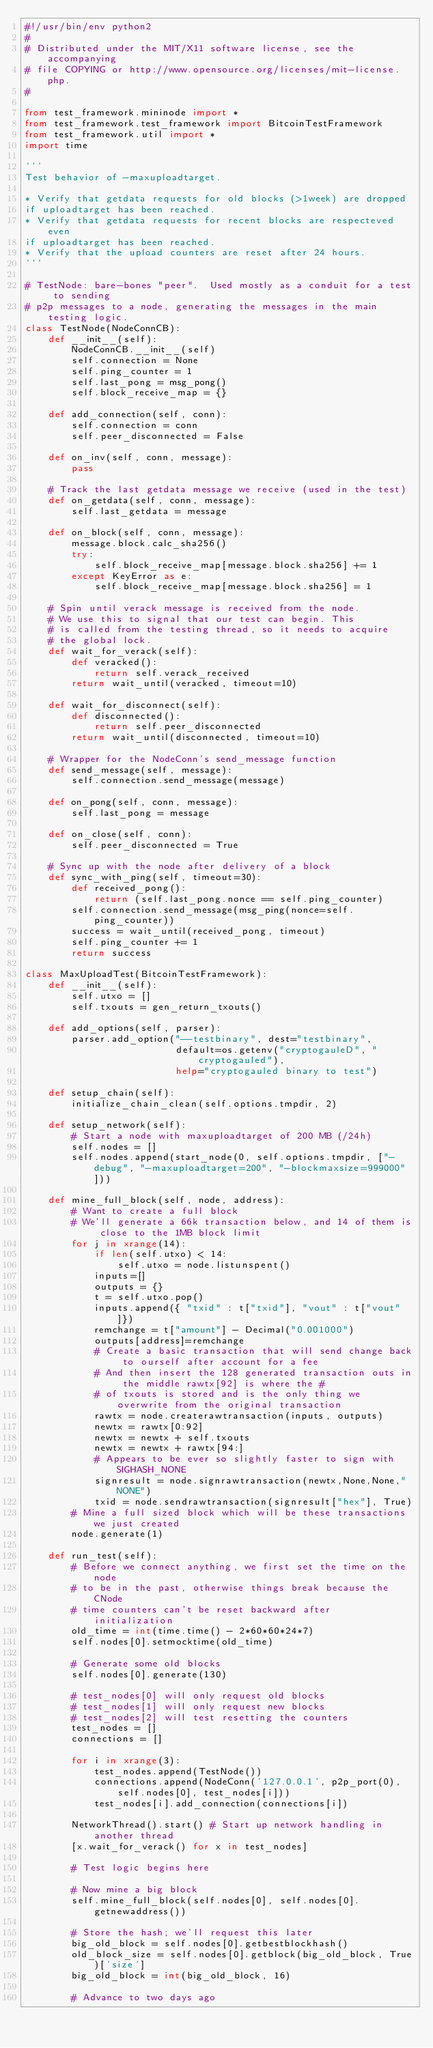<code> <loc_0><loc_0><loc_500><loc_500><_Python_>#!/usr/bin/env python2
#
# Distributed under the MIT/X11 software license, see the accompanying
# file COPYING or http://www.opensource.org/licenses/mit-license.php.
#

from test_framework.mininode import *
from test_framework.test_framework import BitcoinTestFramework
from test_framework.util import *
import time

'''
Test behavior of -maxuploadtarget.

* Verify that getdata requests for old blocks (>1week) are dropped
if uploadtarget has been reached.
* Verify that getdata requests for recent blocks are respecteved even
if uploadtarget has been reached.
* Verify that the upload counters are reset after 24 hours.
'''

# TestNode: bare-bones "peer".  Used mostly as a conduit for a test to sending
# p2p messages to a node, generating the messages in the main testing logic.
class TestNode(NodeConnCB):
    def __init__(self):
        NodeConnCB.__init__(self)
        self.connection = None
        self.ping_counter = 1
        self.last_pong = msg_pong()
        self.block_receive_map = {}

    def add_connection(self, conn):
        self.connection = conn
        self.peer_disconnected = False

    def on_inv(self, conn, message):
        pass

    # Track the last getdata message we receive (used in the test)
    def on_getdata(self, conn, message):
        self.last_getdata = message

    def on_block(self, conn, message):
        message.block.calc_sha256()
        try:
            self.block_receive_map[message.block.sha256] += 1
        except KeyError as e:
            self.block_receive_map[message.block.sha256] = 1

    # Spin until verack message is received from the node.
    # We use this to signal that our test can begin. This
    # is called from the testing thread, so it needs to acquire
    # the global lock.
    def wait_for_verack(self):
        def veracked():
            return self.verack_received
        return wait_until(veracked, timeout=10)

    def wait_for_disconnect(self):
        def disconnected():
            return self.peer_disconnected
        return wait_until(disconnected, timeout=10)

    # Wrapper for the NodeConn's send_message function
    def send_message(self, message):
        self.connection.send_message(message)

    def on_pong(self, conn, message):
        self.last_pong = message

    def on_close(self, conn):
        self.peer_disconnected = True

    # Sync up with the node after delivery of a block
    def sync_with_ping(self, timeout=30):
        def received_pong():
            return (self.last_pong.nonce == self.ping_counter)
        self.connection.send_message(msg_ping(nonce=self.ping_counter))
        success = wait_until(received_pong, timeout)
        self.ping_counter += 1
        return success

class MaxUploadTest(BitcoinTestFramework):
    def __init__(self):
        self.utxo = []
        self.txouts = gen_return_txouts()
 
    def add_options(self, parser):
        parser.add_option("--testbinary", dest="testbinary",
                          default=os.getenv("cryptogauleD", "cryptogauled"),
                          help="cryptogauled binary to test")

    def setup_chain(self):
        initialize_chain_clean(self.options.tmpdir, 2)

    def setup_network(self):
        # Start a node with maxuploadtarget of 200 MB (/24h)
        self.nodes = []
        self.nodes.append(start_node(0, self.options.tmpdir, ["-debug", "-maxuploadtarget=200", "-blockmaxsize=999000"]))

    def mine_full_block(self, node, address):
        # Want to create a full block
        # We'll generate a 66k transaction below, and 14 of them is close to the 1MB block limit
        for j in xrange(14):
            if len(self.utxo) < 14:
                self.utxo = node.listunspent()
            inputs=[]
            outputs = {}
            t = self.utxo.pop()
            inputs.append({ "txid" : t["txid"], "vout" : t["vout"]})
            remchange = t["amount"] - Decimal("0.001000")
            outputs[address]=remchange
            # Create a basic transaction that will send change back to ourself after account for a fee
            # And then insert the 128 generated transaction outs in the middle rawtx[92] is where the #
            # of txouts is stored and is the only thing we overwrite from the original transaction
            rawtx = node.createrawtransaction(inputs, outputs)
            newtx = rawtx[0:92]
            newtx = newtx + self.txouts
            newtx = newtx + rawtx[94:]
            # Appears to be ever so slightly faster to sign with SIGHASH_NONE
            signresult = node.signrawtransaction(newtx,None,None,"NONE")
            txid = node.sendrawtransaction(signresult["hex"], True)
        # Mine a full sized block which will be these transactions we just created
        node.generate(1)

    def run_test(self):
        # Before we connect anything, we first set the time on the node
        # to be in the past, otherwise things break because the CNode
        # time counters can't be reset backward after initialization
        old_time = int(time.time() - 2*60*60*24*7)
        self.nodes[0].setmocktime(old_time)

        # Generate some old blocks
        self.nodes[0].generate(130)

        # test_nodes[0] will only request old blocks
        # test_nodes[1] will only request new blocks
        # test_nodes[2] will test resetting the counters
        test_nodes = []
        connections = []

        for i in xrange(3):
            test_nodes.append(TestNode())
            connections.append(NodeConn('127.0.0.1', p2p_port(0), self.nodes[0], test_nodes[i]))
            test_nodes[i].add_connection(connections[i])

        NetworkThread().start() # Start up network handling in another thread
        [x.wait_for_verack() for x in test_nodes]

        # Test logic begins here

        # Now mine a big block
        self.mine_full_block(self.nodes[0], self.nodes[0].getnewaddress())

        # Store the hash; we'll request this later
        big_old_block = self.nodes[0].getbestblockhash()
        old_block_size = self.nodes[0].getblock(big_old_block, True)['size']
        big_old_block = int(big_old_block, 16)

        # Advance to two days ago</code> 